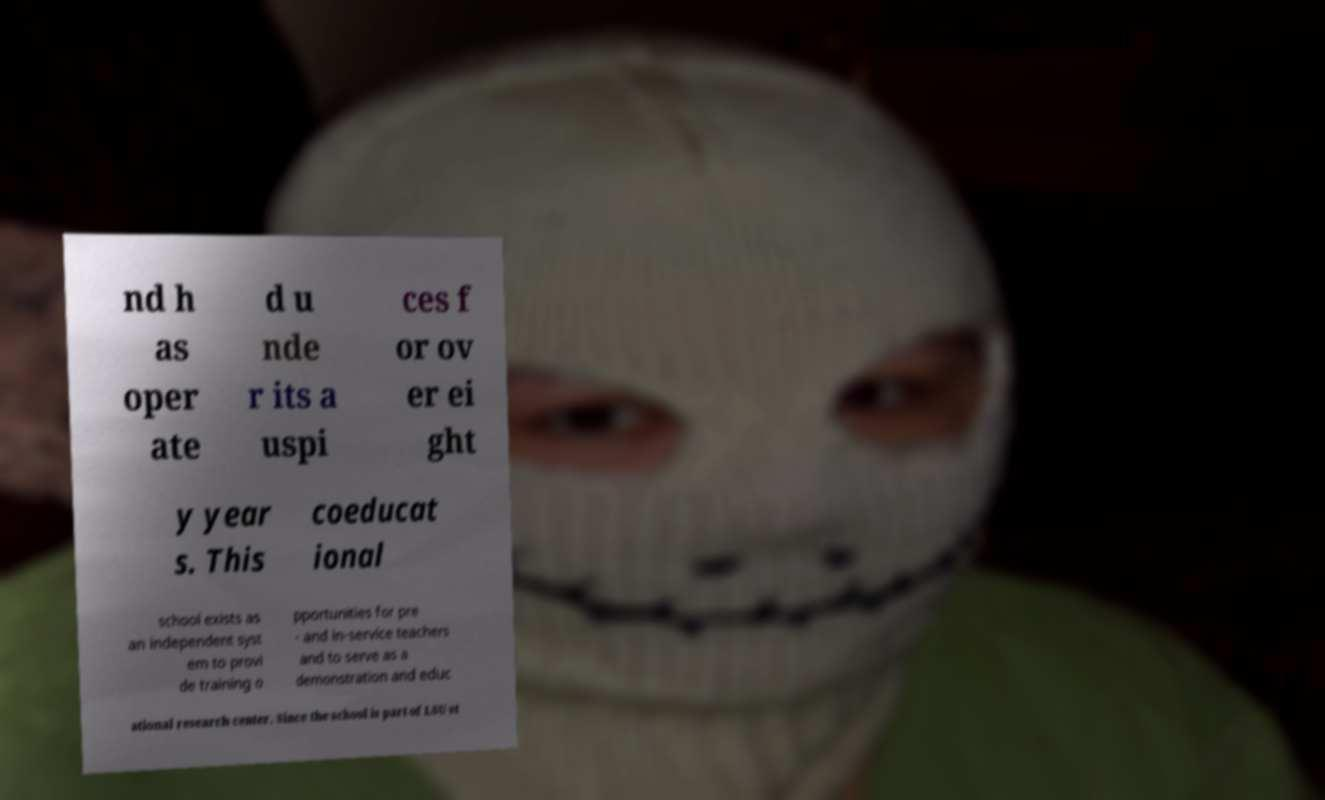What messages or text are displayed in this image? I need them in a readable, typed format. nd h as oper ate d u nde r its a uspi ces f or ov er ei ght y year s. This coeducat ional school exists as an independent syst em to provi de training o pportunities for pre - and in-service teachers and to serve as a demonstration and educ ational research center. Since the school is part of LSU st 